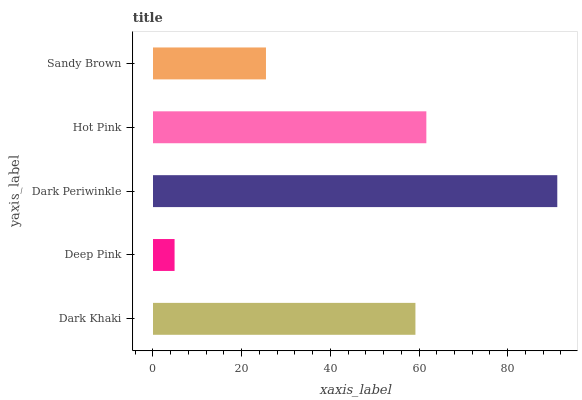Is Deep Pink the minimum?
Answer yes or no. Yes. Is Dark Periwinkle the maximum?
Answer yes or no. Yes. Is Dark Periwinkle the minimum?
Answer yes or no. No. Is Deep Pink the maximum?
Answer yes or no. No. Is Dark Periwinkle greater than Deep Pink?
Answer yes or no. Yes. Is Deep Pink less than Dark Periwinkle?
Answer yes or no. Yes. Is Deep Pink greater than Dark Periwinkle?
Answer yes or no. No. Is Dark Periwinkle less than Deep Pink?
Answer yes or no. No. Is Dark Khaki the high median?
Answer yes or no. Yes. Is Dark Khaki the low median?
Answer yes or no. Yes. Is Hot Pink the high median?
Answer yes or no. No. Is Sandy Brown the low median?
Answer yes or no. No. 